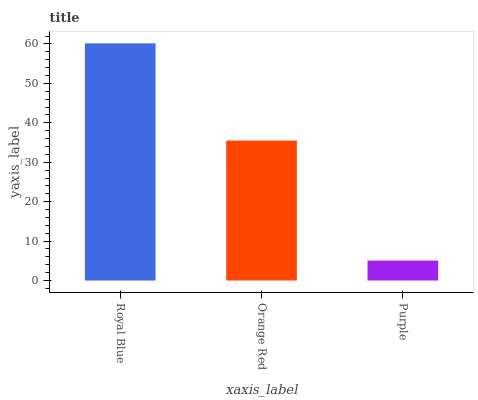Is Orange Red the minimum?
Answer yes or no. No. Is Orange Red the maximum?
Answer yes or no. No. Is Royal Blue greater than Orange Red?
Answer yes or no. Yes. Is Orange Red less than Royal Blue?
Answer yes or no. Yes. Is Orange Red greater than Royal Blue?
Answer yes or no. No. Is Royal Blue less than Orange Red?
Answer yes or no. No. Is Orange Red the high median?
Answer yes or no. Yes. Is Orange Red the low median?
Answer yes or no. Yes. Is Purple the high median?
Answer yes or no. No. Is Royal Blue the low median?
Answer yes or no. No. 